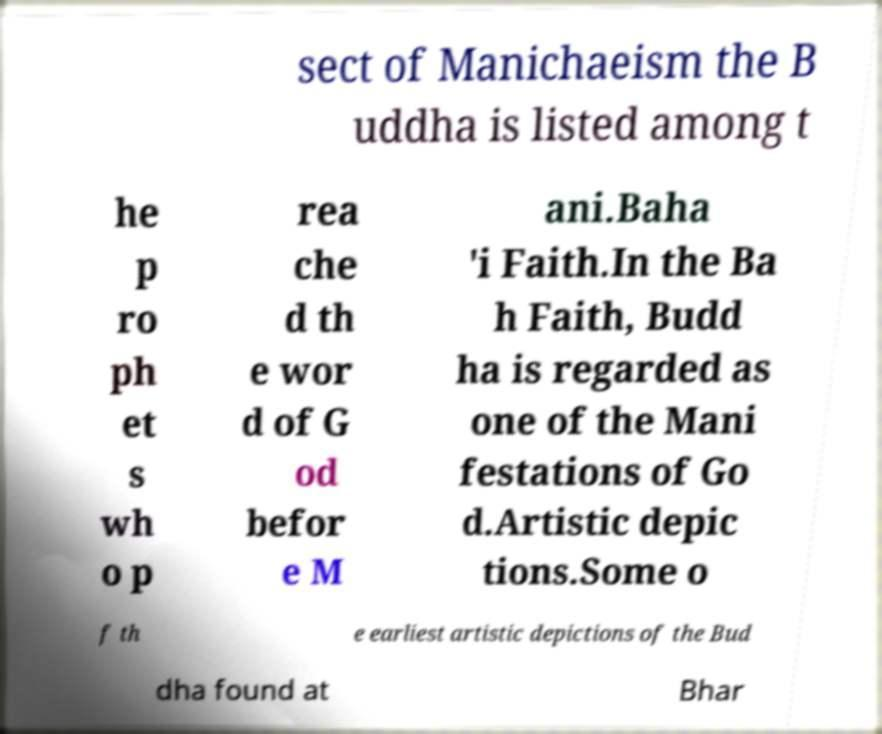What messages or text are displayed in this image? I need them in a readable, typed format. sect of Manichaeism the B uddha is listed among t he p ro ph et s wh o p rea che d th e wor d of G od befor e M ani.Baha 'i Faith.In the Ba h Faith, Budd ha is regarded as one of the Mani festations of Go d.Artistic depic tions.Some o f th e earliest artistic depictions of the Bud dha found at Bhar 